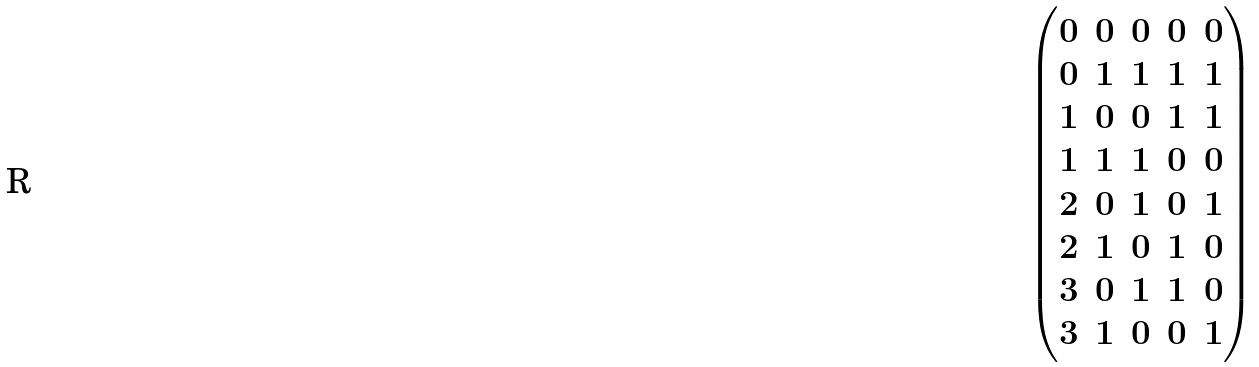Convert formula to latex. <formula><loc_0><loc_0><loc_500><loc_500>\begin{pmatrix} 0 & 0 & 0 & 0 & 0 \\ 0 & 1 & 1 & 1 & 1 \\ 1 & 0 & 0 & 1 & 1 \\ 1 & 1 & 1 & 0 & 0 \\ 2 & 0 & 1 & 0 & 1 \\ 2 & 1 & 0 & 1 & 0 \\ 3 & 0 & 1 & 1 & 0 \\ 3 & 1 & 0 & 0 & 1 \\ \end{pmatrix}</formula> 